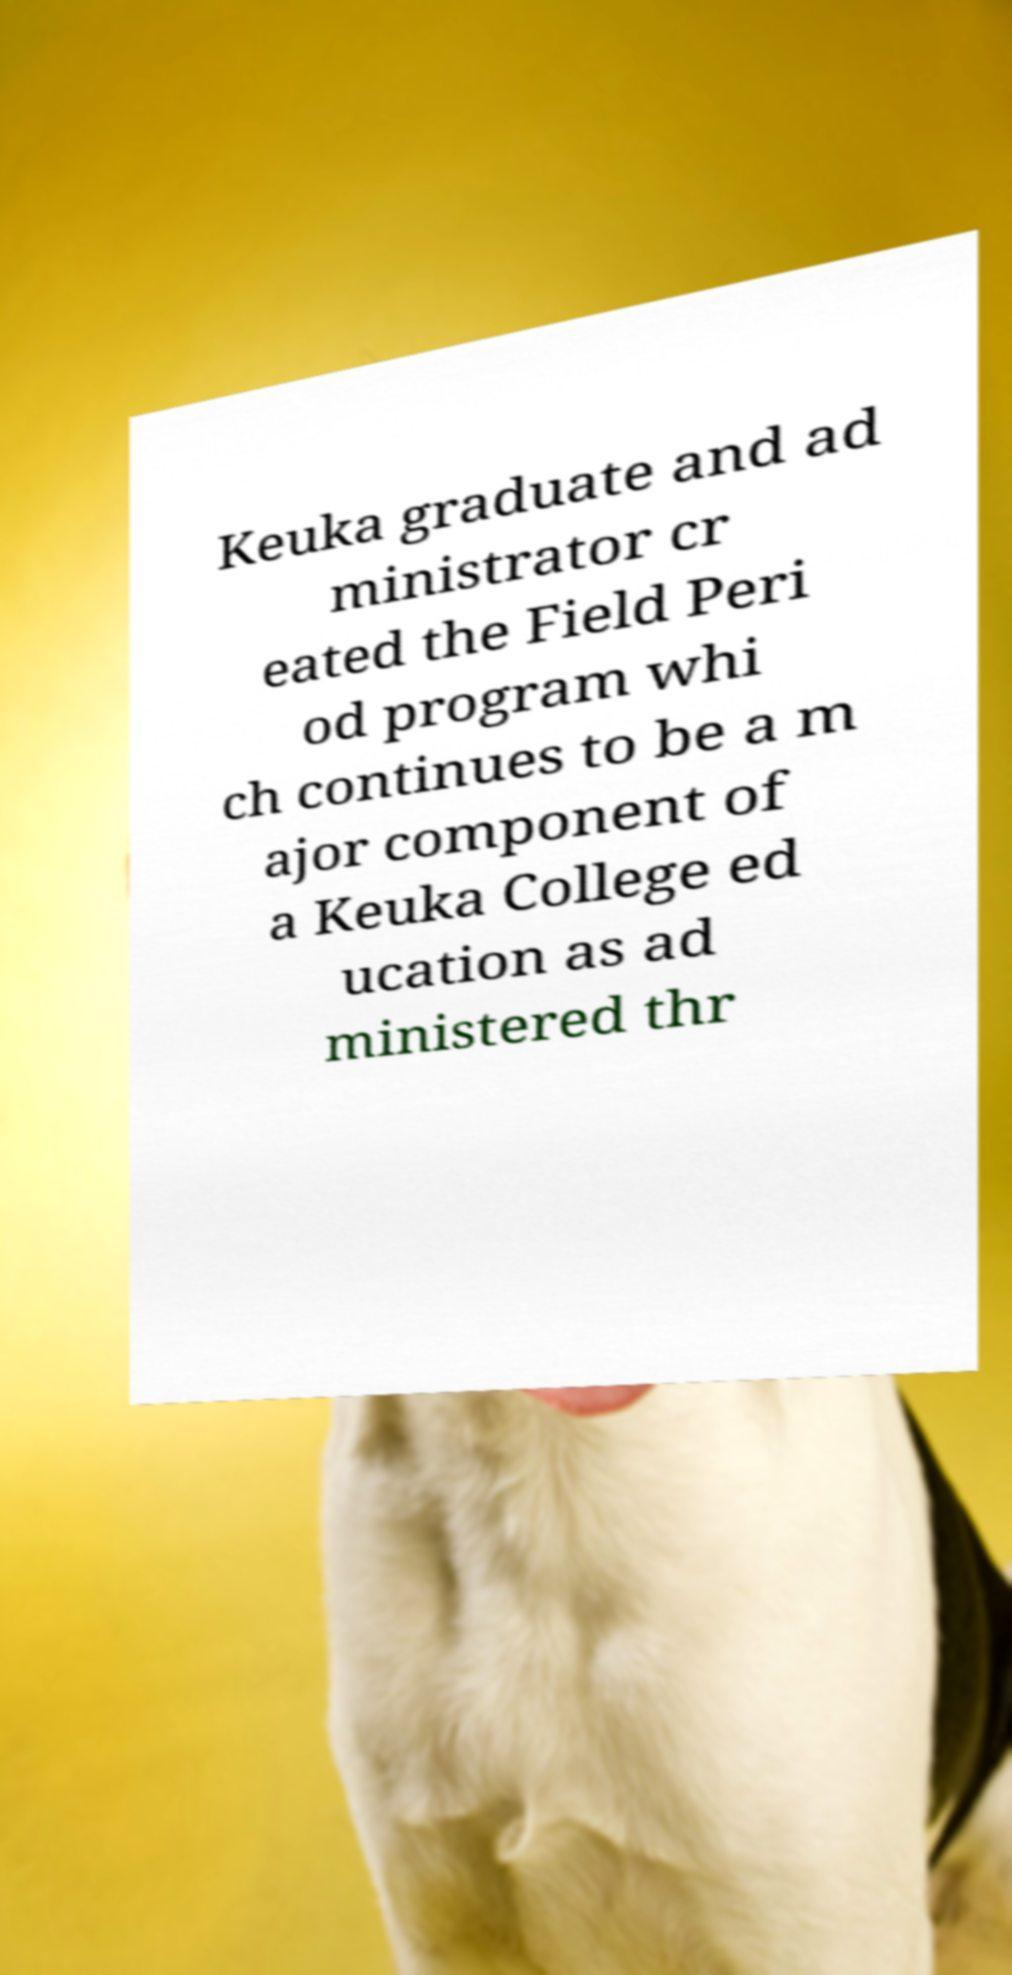Could you extract and type out the text from this image? Keuka graduate and ad ministrator cr eated the Field Peri od program whi ch continues to be a m ajor component of a Keuka College ed ucation as ad ministered thr 